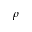Convert formula to latex. <formula><loc_0><loc_0><loc_500><loc_500>\rho</formula> 